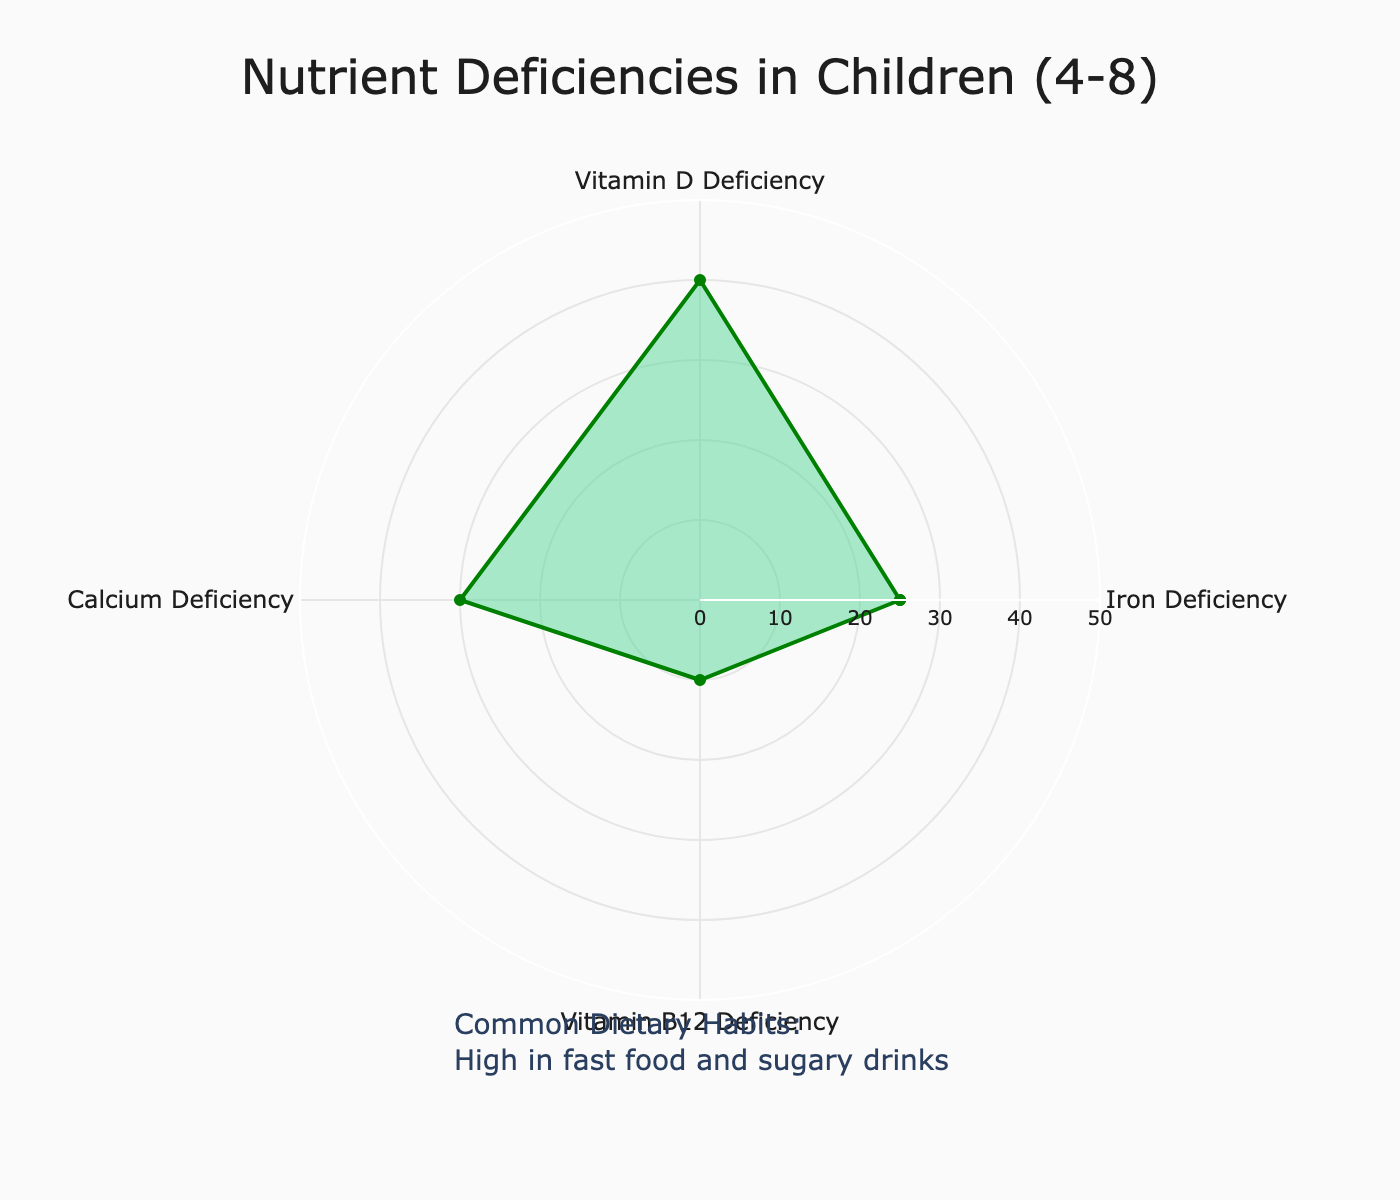What is the title of the radar chart? The title is the text at the top center of the chart. It helps identify the main subject of the figure.
Answer: Nutrient Deficiencies in Children (4-8) How many categories of nutrient deficiencies are displayed? The categories are labeled around the radar chart's circumference. By counting these labels, we can determine how many categories are displayed.
Answer: Four Which nutrient deficiency has the highest value in children aged 4-8? By examining the lengths of the radial arms or the positions of the data points, we can see which one has the highest value.
Answer: Vitamin D Deficiency What are the common dietary habits mentioned? The common dietary habits are annotated at the bottom of the chart.
Answer: High in fast food and sugary drinks Calculate the difference between the highest and lowest nutrient deficiency values. The highest value is 40 (Vitamin D Deficiency) and the lowest is 10 (Vitamin B12 Deficiency). Subtracting the lowest from the highest gives the difference.
Answer: 30 Which nutrient deficiencies have values greater than 25? By checking the values against 25, we find which ones are greater.
Answer: Vitamin D Deficiency and Calcium Deficiency What is the average value of all the nutrient deficiencies? Add all nutrient deficiency values (25 + 40 + 30 + 10) and divide by the number of categories (4). The sum is 105, so the average is 105/4.
Answer: 26.25 Is Iron Deficiency higher or lower than Calcium Deficiency? Compare the values of Iron Deficiency (25) and Calcium Deficiency (30).
Answer: Lower What is the color of the filled area of the radar chart? The filled area is the colored region inside the radar chart. This can be observed directly.
Answer: Light green How does Vitamin B12 Deficiency compare to Iron Deficiency? Comparing the values for Vitamin B12 Deficiency (10) and Iron Deficiency (25) shows the relationship between the two.
Answer: Lower 